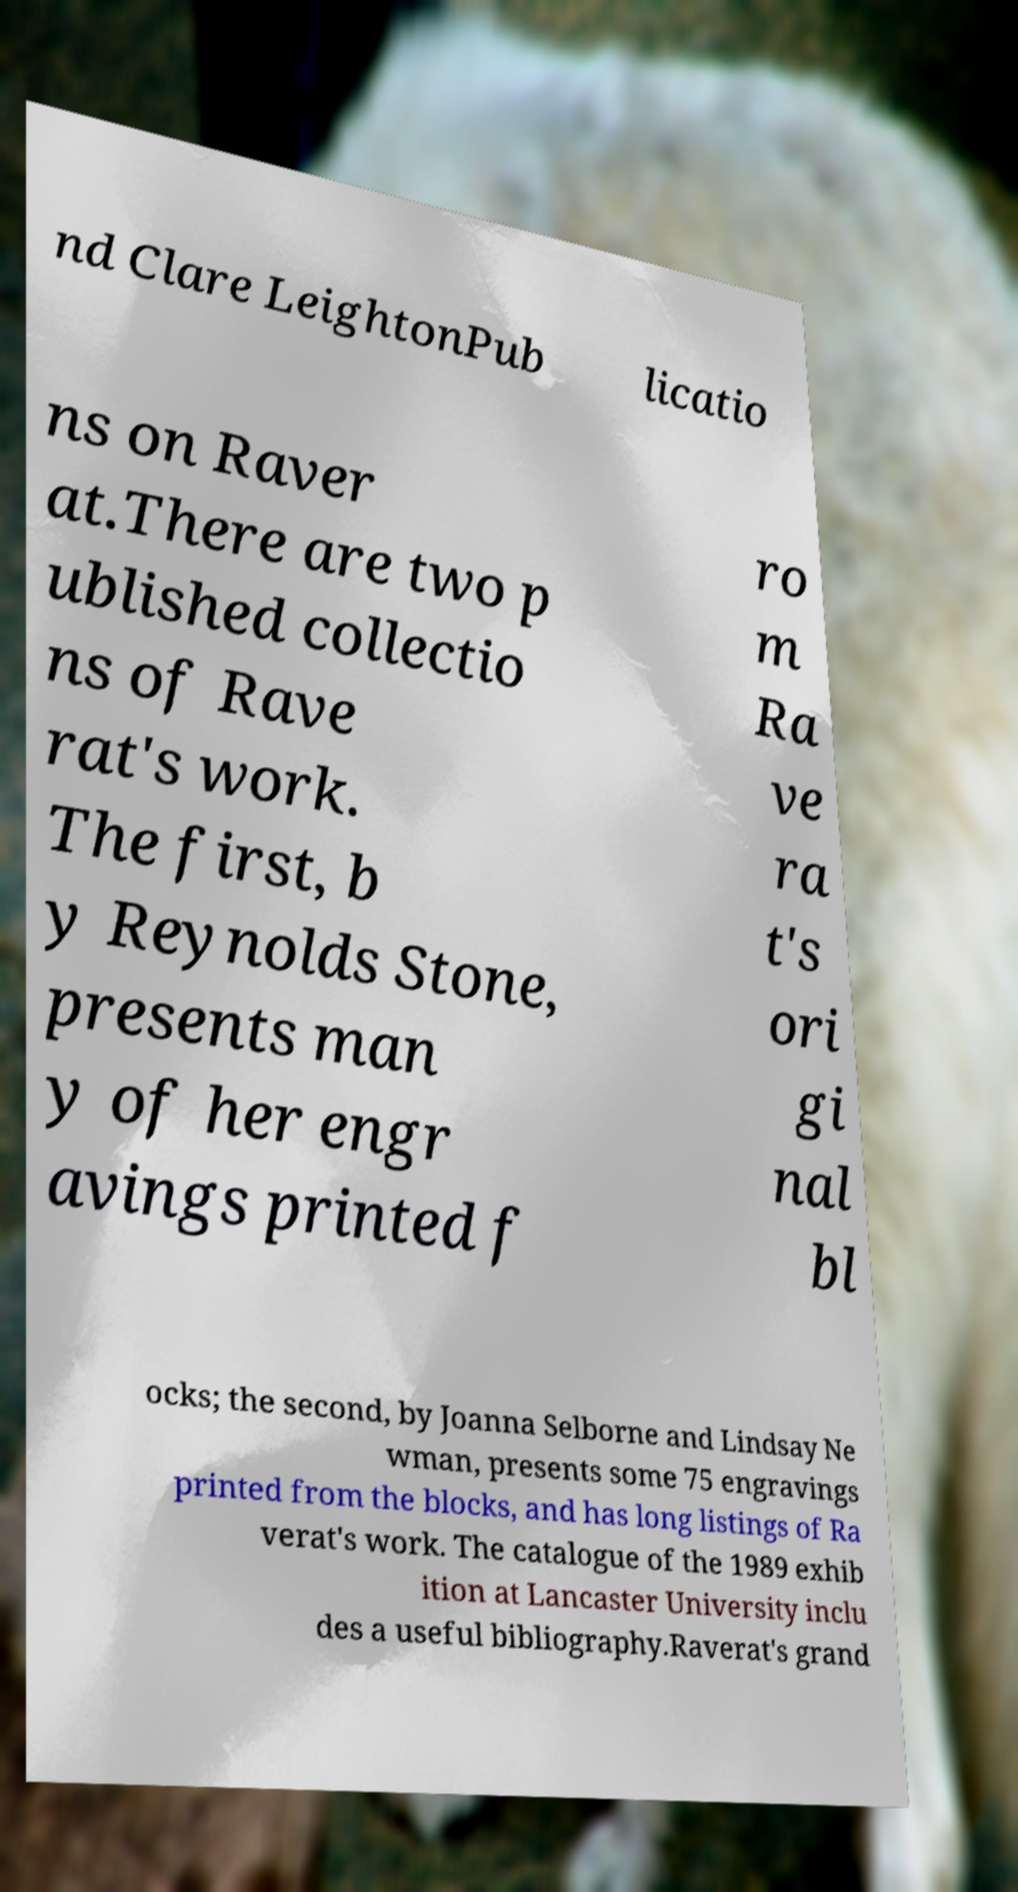For documentation purposes, I need the text within this image transcribed. Could you provide that? nd Clare LeightonPub licatio ns on Raver at.There are two p ublished collectio ns of Rave rat's work. The first, b y Reynolds Stone, presents man y of her engr avings printed f ro m Ra ve ra t's ori gi nal bl ocks; the second, by Joanna Selborne and Lindsay Ne wman, presents some 75 engravings printed from the blocks, and has long listings of Ra verat's work. The catalogue of the 1989 exhib ition at Lancaster University inclu des a useful bibliography.Raverat's grand 